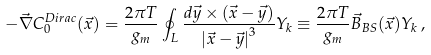<formula> <loc_0><loc_0><loc_500><loc_500>- \vec { \nabla } { C } _ { 0 } ^ { D i r a c } ( { \vec { x } } ) = \frac { 2 \pi T } { g _ { m } } \oint _ { L } { \frac { d { \vec { y } } \times { ( \vec { x } - \vec { y } ) } } { { | \vec { x } - \vec { y } | } ^ { 3 } } } { Y } _ { k } \equiv \frac { 2 \pi T } { g _ { m } } { \vec { B } } _ { B S } ( \vec { x } ) { Y } _ { k } \, ,</formula> 